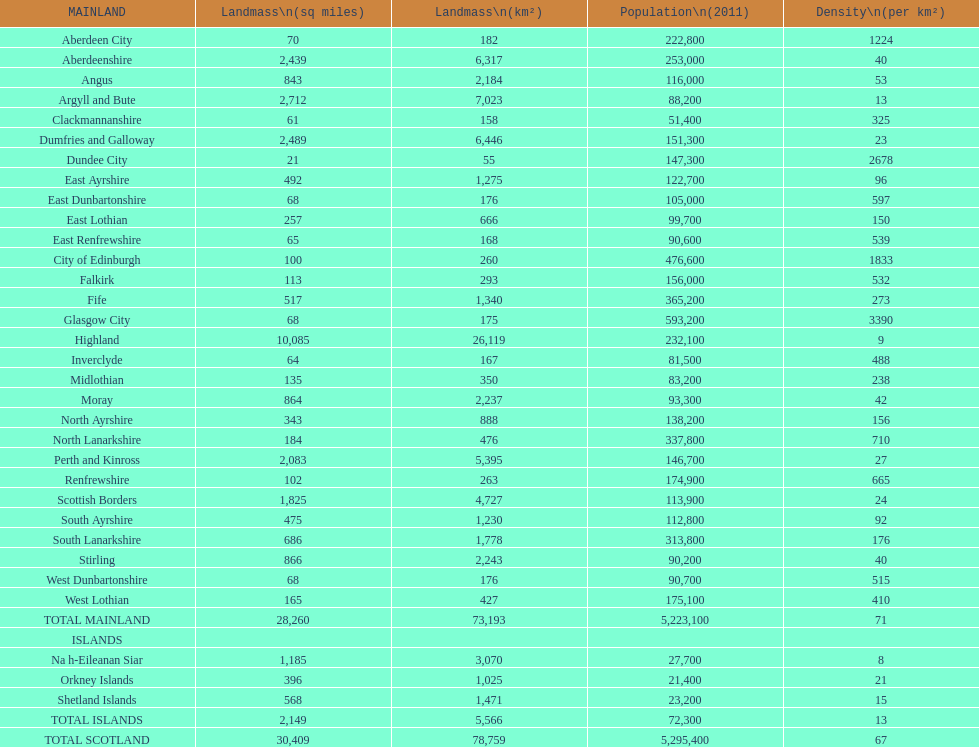If you were to arrange the locations from the smallest to largest area, which one would be first on the list? Dundee City. 